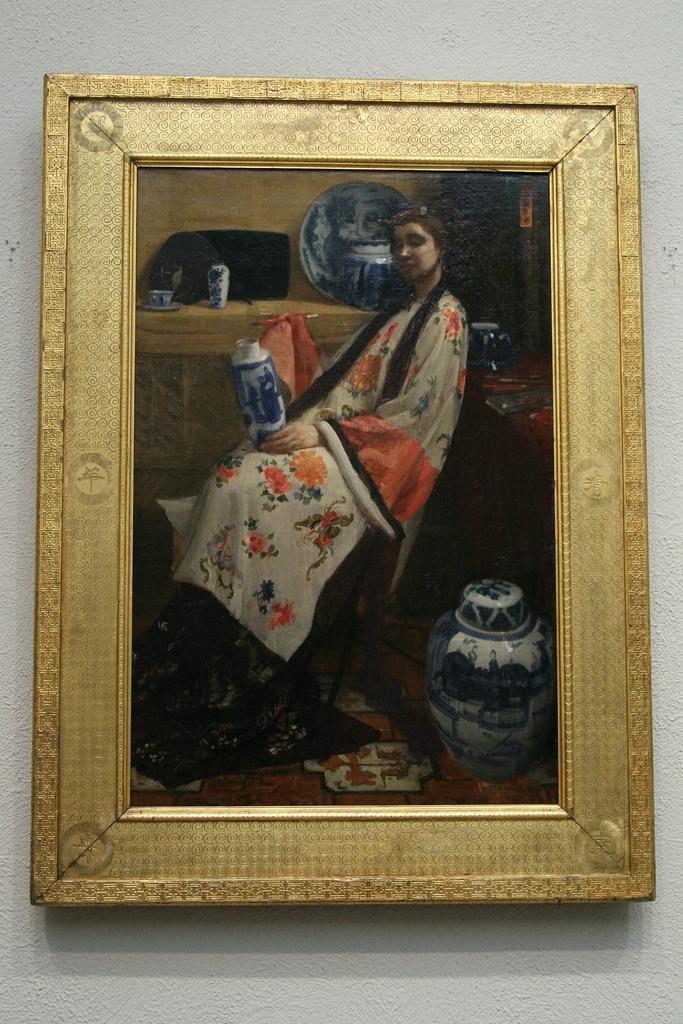Can you describe this image briefly? In this picture we can see a frame on the wall and on this frame we can see some objects and a woman. 